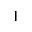<formula> <loc_0><loc_0><loc_500><loc_500>|</formula> 